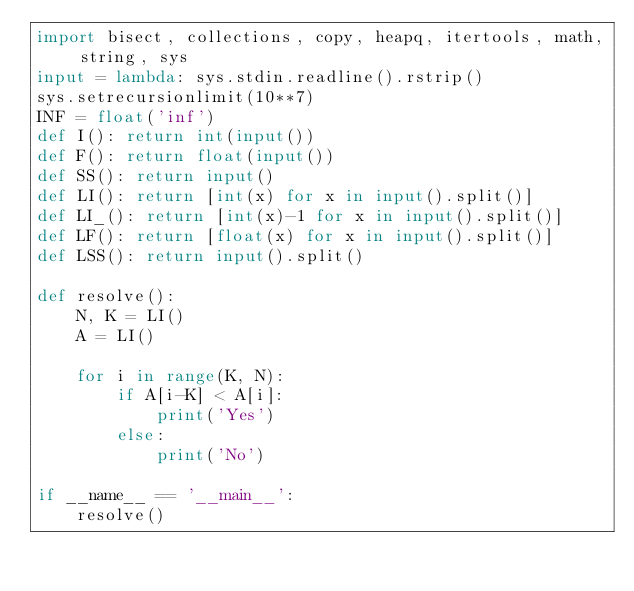Convert code to text. <code><loc_0><loc_0><loc_500><loc_500><_Python_>import bisect, collections, copy, heapq, itertools, math, string, sys
input = lambda: sys.stdin.readline().rstrip() 
sys.setrecursionlimit(10**7)
INF = float('inf')
def I(): return int(input())
def F(): return float(input())
def SS(): return input()
def LI(): return [int(x) for x in input().split()]
def LI_(): return [int(x)-1 for x in input().split()]
def LF(): return [float(x) for x in input().split()]
def LSS(): return input().split()

def resolve():
    N, K = LI()
    A = LI()

    for i in range(K, N):
        if A[i-K] < A[i]:
            print('Yes')
        else:
            print('No')

if __name__ == '__main__':
    resolve()
</code> 